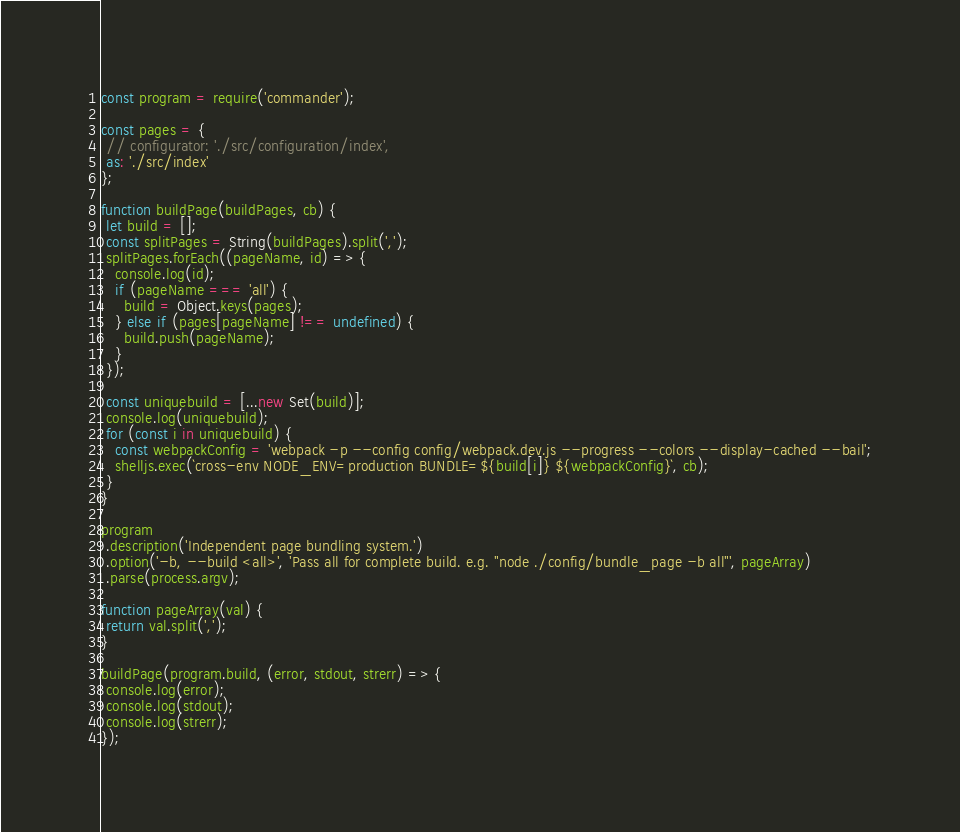Convert code to text. <code><loc_0><loc_0><loc_500><loc_500><_JavaScript_>const program = require('commander');

const pages = {
 // configurator: './src/configuration/index',
 as: './src/index'
};

function buildPage(buildPages, cb) {
 let build = [];
 const splitPages = String(buildPages).split(',');
 splitPages.forEach((pageName, id) => {
   console.log(id);
   if (pageName === 'all') {
     build = Object.keys(pages);
   } else if (pages[pageName] !== undefined) {
     build.push(pageName);
   }
 });

 const uniquebuild = [...new Set(build)];
 console.log(uniquebuild);
 for (const i in uniquebuild) {
   const webpackConfig = 'webpack -p --config config/webpack.dev.js --progress --colors --display-cached --bail';
   shelljs.exec(`cross-env NODE_ENV=production BUNDLE=${build[i]} ${webpackConfig}`, cb);
 }
}

program
 .description('Independent page bundling system.')
 .option('-b, --build <all>', 'Pass all for complete build. e.g. "node ./config/bundle_page -b all"', pageArray)
 .parse(process.argv);

function pageArray(val) {
 return val.split(',');
}

buildPage(program.build, (error, stdout, strerr) => {
 console.log(error);
 console.log(stdout);
 console.log(strerr);
});</code> 